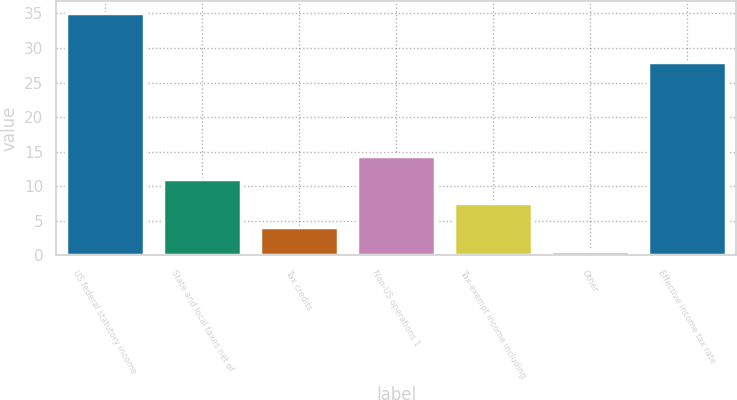Convert chart. <chart><loc_0><loc_0><loc_500><loc_500><bar_chart><fcel>US federal statutory income<fcel>State and local taxes net of<fcel>Tax credits<fcel>Non-US operations 1<fcel>Tax-exempt income including<fcel>Other<fcel>Effective income tax rate<nl><fcel>35<fcel>10.99<fcel>4.13<fcel>14.42<fcel>7.56<fcel>0.7<fcel>28<nl></chart> 